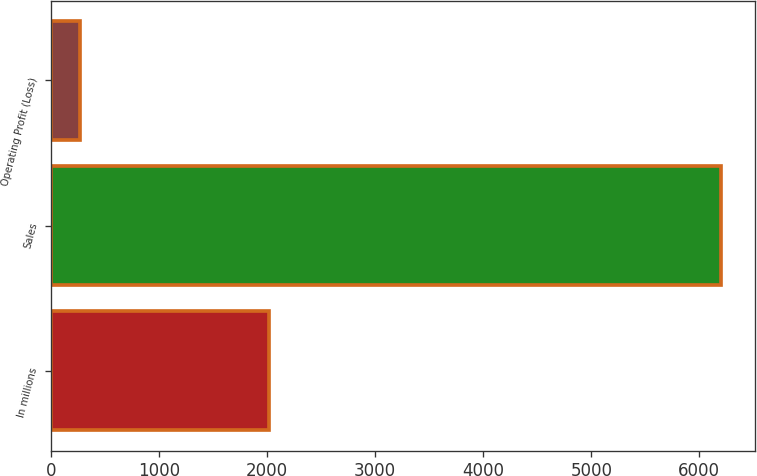Convert chart. <chart><loc_0><loc_0><loc_500><loc_500><bar_chart><fcel>In millions<fcel>Sales<fcel>Operating Profit (Loss)<nl><fcel>2013<fcel>6205<fcel>271<nl></chart> 